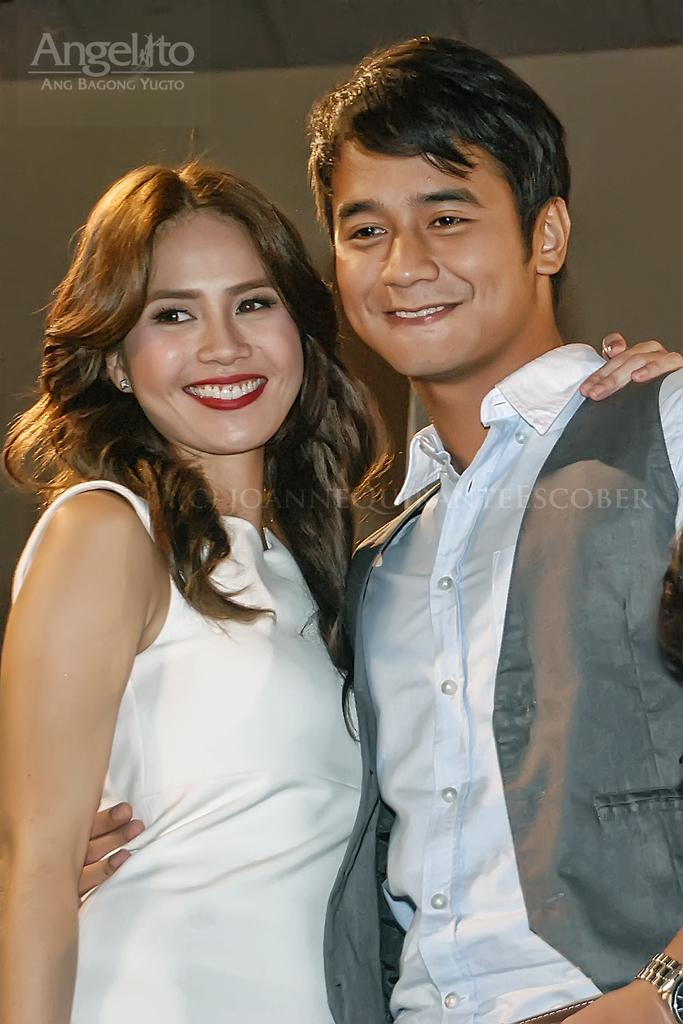How many people are in the image? There are two persons in the image. What expressions do the persons have on their faces? The persons are wearing smiles on their faces. What can be seen in the background of the image? There is a wall visible in the image. What type of jellyfish can be seen swimming near the persons in the image? There are no jellyfish present in the image; it features two smiling persons and a wall in the background. 